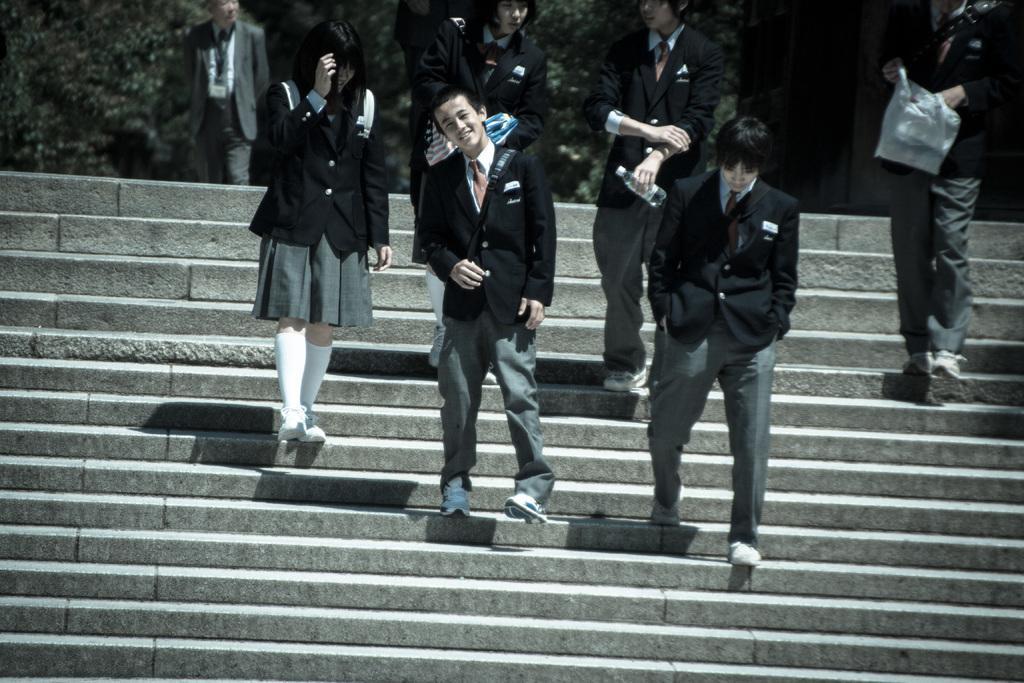How would you summarize this image in a sentence or two? In this picture there are group of people on the staircase. At the back there are trees and there is a person walking. 